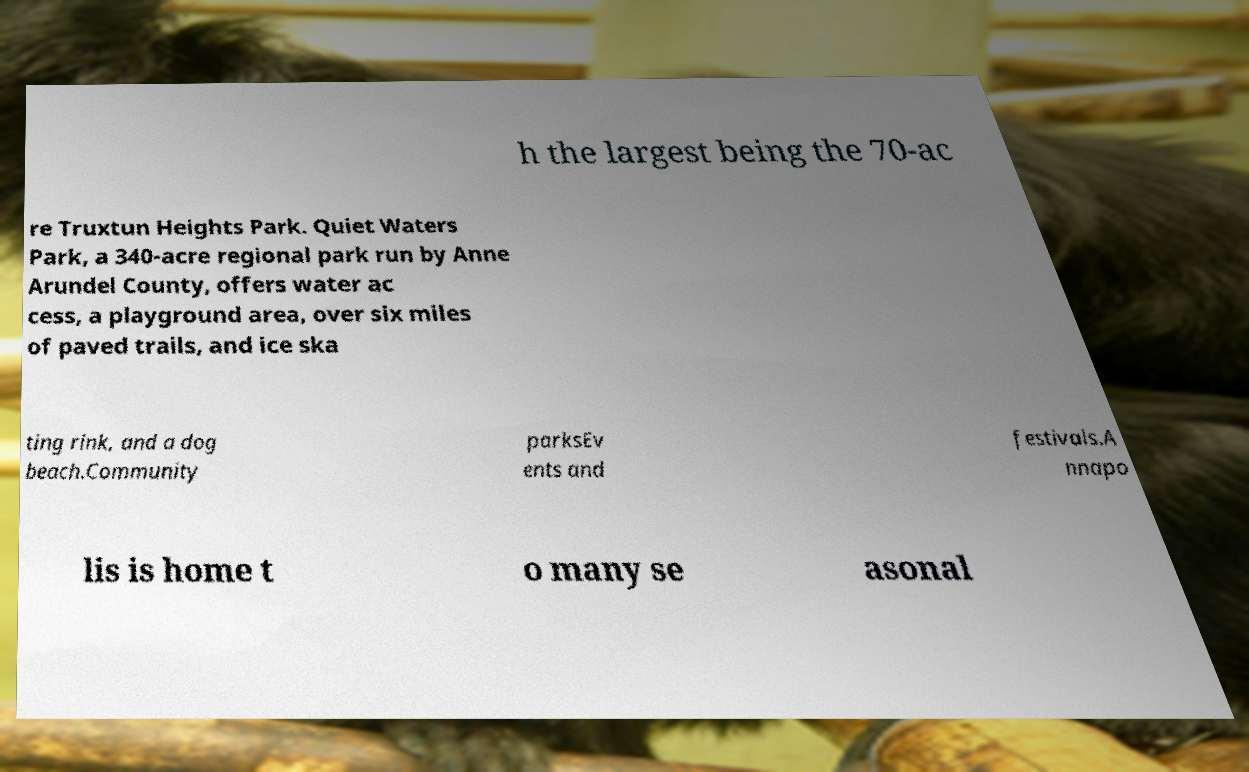Please identify and transcribe the text found in this image. h the largest being the 70-ac re Truxtun Heights Park. Quiet Waters Park, a 340-acre regional park run by Anne Arundel County, offers water ac cess, a playground area, over six miles of paved trails, and ice ska ting rink, and a dog beach.Community parksEv ents and festivals.A nnapo lis is home t o many se asonal 